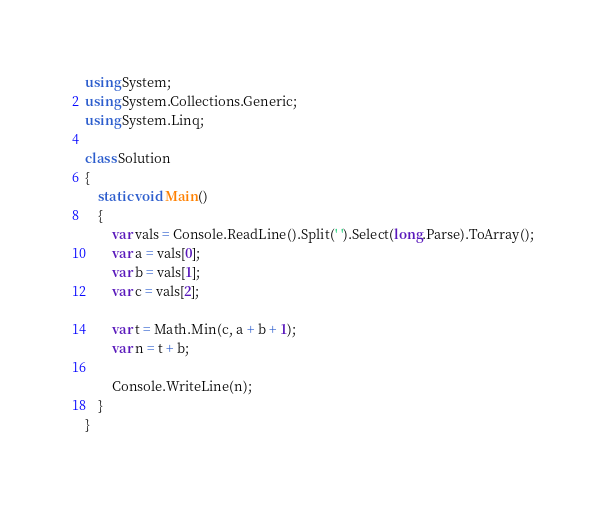<code> <loc_0><loc_0><loc_500><loc_500><_C#_>using System;
using System.Collections.Generic;
using System.Linq;

class Solution
{
    static void Main()
    {
        var vals = Console.ReadLine().Split(' ').Select(long.Parse).ToArray();
        var a = vals[0];
        var b = vals[1];
        var c = vals[2];

        var t = Math.Min(c, a + b + 1);
        var n = t + b;

        Console.WriteLine(n);
    }
}</code> 